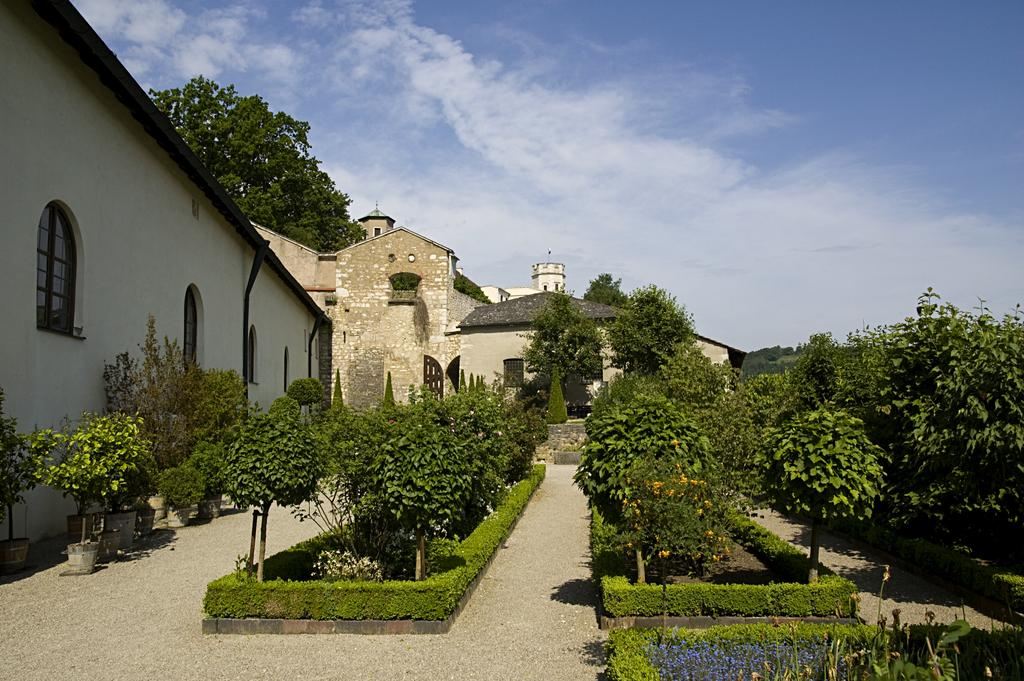What type of plants can be seen in the image? There are houseplants and plants on the ground in the image. What can be seen in the background of the image? There are buildings, trees, and the sky visible in the background of the image. What type of liquid is being processed by the face in the image? There is no face or liquid present in the image. 